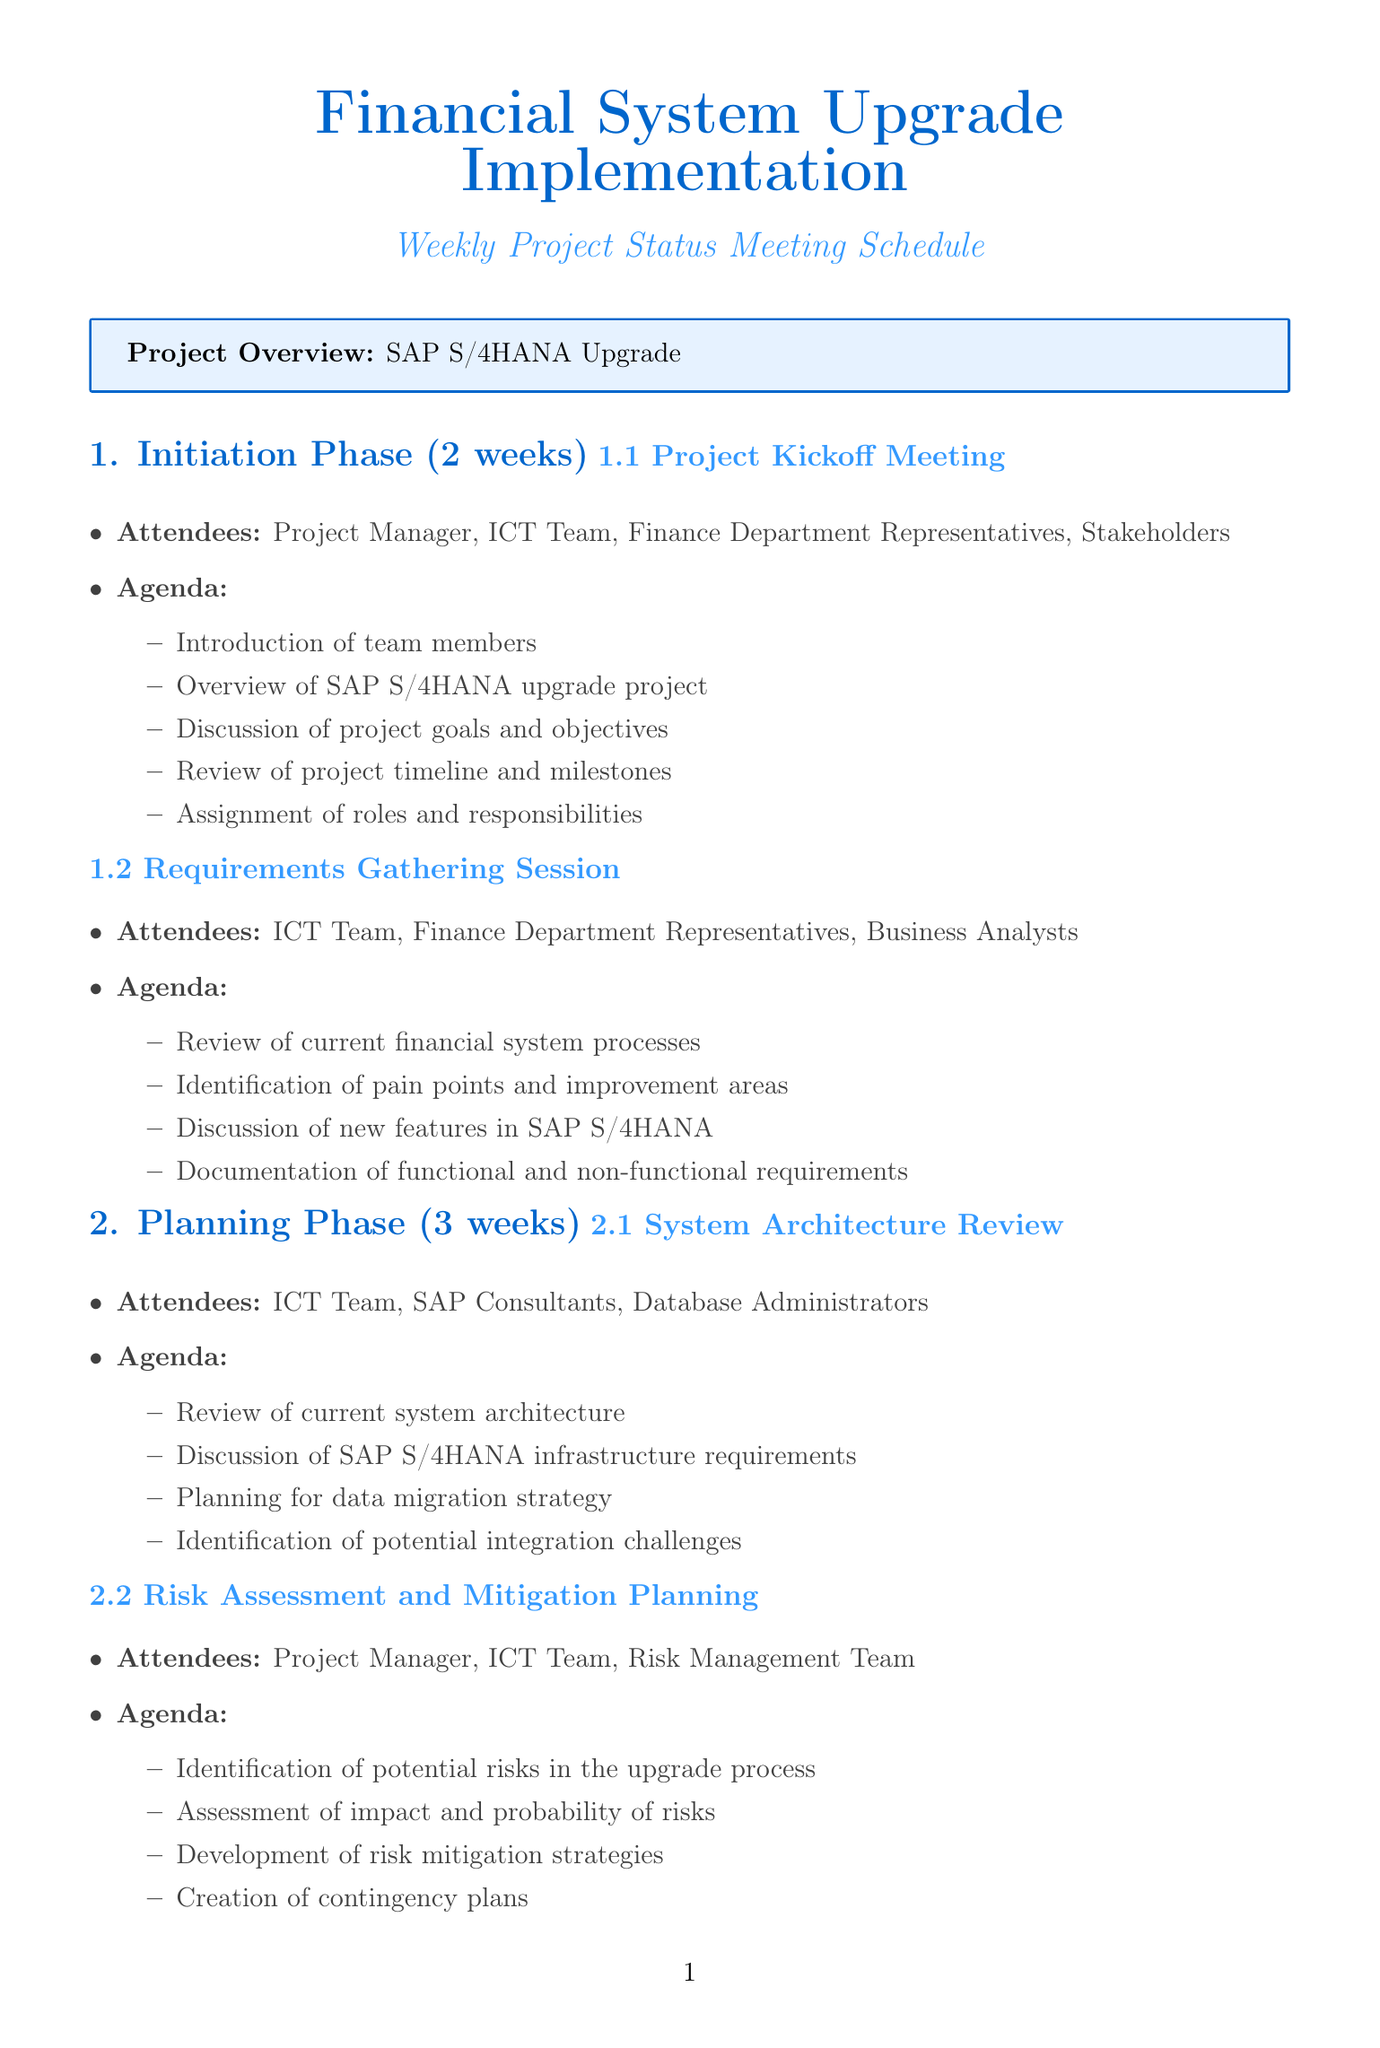What is the duration of the Execution phase? The duration of the Execution phase is specified in the document as 12 weeks.
Answer: 12 weeks Who are the attendees of the UAT Kickoff Session? The attendees for the UAT Kickoff Session are listed in the document, including the ICT Team, Finance Department Representatives, and End Users.
Answer: ICT Team, Finance Department Representatives, End Users How many weeks is the Planning phase? The duration of the Planning phase is provided in the document. It is stated as 3 weeks.
Answer: 3 weeks What is one key topic discussed in the Data Migration Status Update meeting? The agenda for the Data Migration Status Update includes topics like "Progress report on data cleansing and preparation," which is one key item discussed.
Answer: Progress report on data cleansing and preparation What is a main focus of the Project Closure and Lessons Learned meeting? The main focus of the Project Closure and Lessons Learned meeting includes collecting lessons learned and best practices according to the agenda outlined in the document.
Answer: Collection of lessons learned and best practices Which team is involved in the Risk Assessment and Mitigation Planning meeting? The authors involved in the Risk Assessment and Mitigation Planning meeting are listed as the Project Manager, ICT Team, and Risk Management Team.
Answer: Project Manager, ICT Team, Risk Management Team What phase includes the Cutover Planning Session? The phase containing the Cutover Planning Session is made clear in the document, specifically under the Go-Live Preparation phase.
Answer: Go-Live Preparation How many meetings are held in the User Acceptance Testing phase? The document states that there are two meetings held in the User Acceptance Testing phase, which includes the UAT Kickoff Session and UAT Progress Review.
Answer: Two meetings 